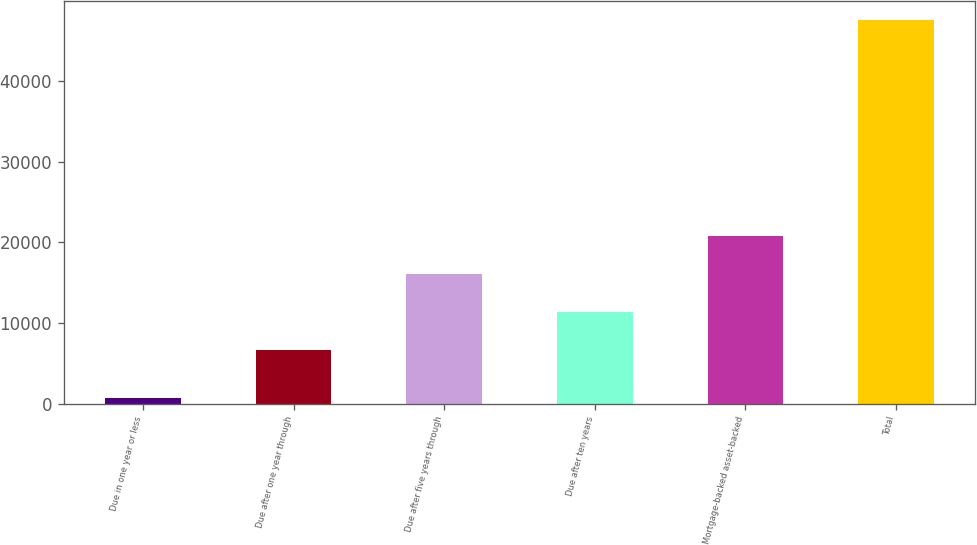<chart> <loc_0><loc_0><loc_500><loc_500><bar_chart><fcel>Due in one year or less<fcel>Due after one year through<fcel>Due after five years through<fcel>Due after ten years<fcel>Mortgage-backed asset-backed<fcel>Total<nl><fcel>637<fcel>6669<fcel>16052.4<fcel>11360.7<fcel>20744.1<fcel>47554<nl></chart> 